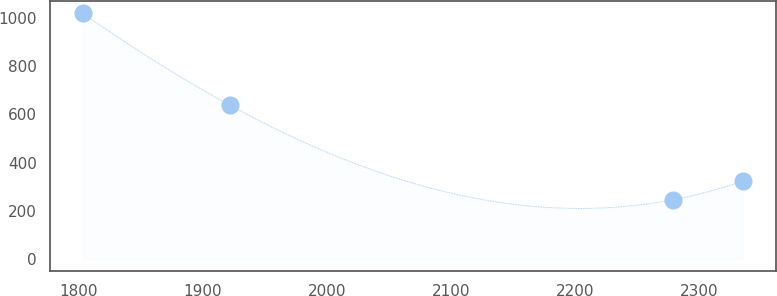Convert chart to OTSL. <chart><loc_0><loc_0><loc_500><loc_500><line_chart><ecel><fcel>Unnamed: 1<nl><fcel>1803.36<fcel>1019.59<nl><fcel>1921.8<fcel>638.55<nl><fcel>2278.62<fcel>246.2<nl><fcel>2334.74<fcel>323.54<nl></chart> 